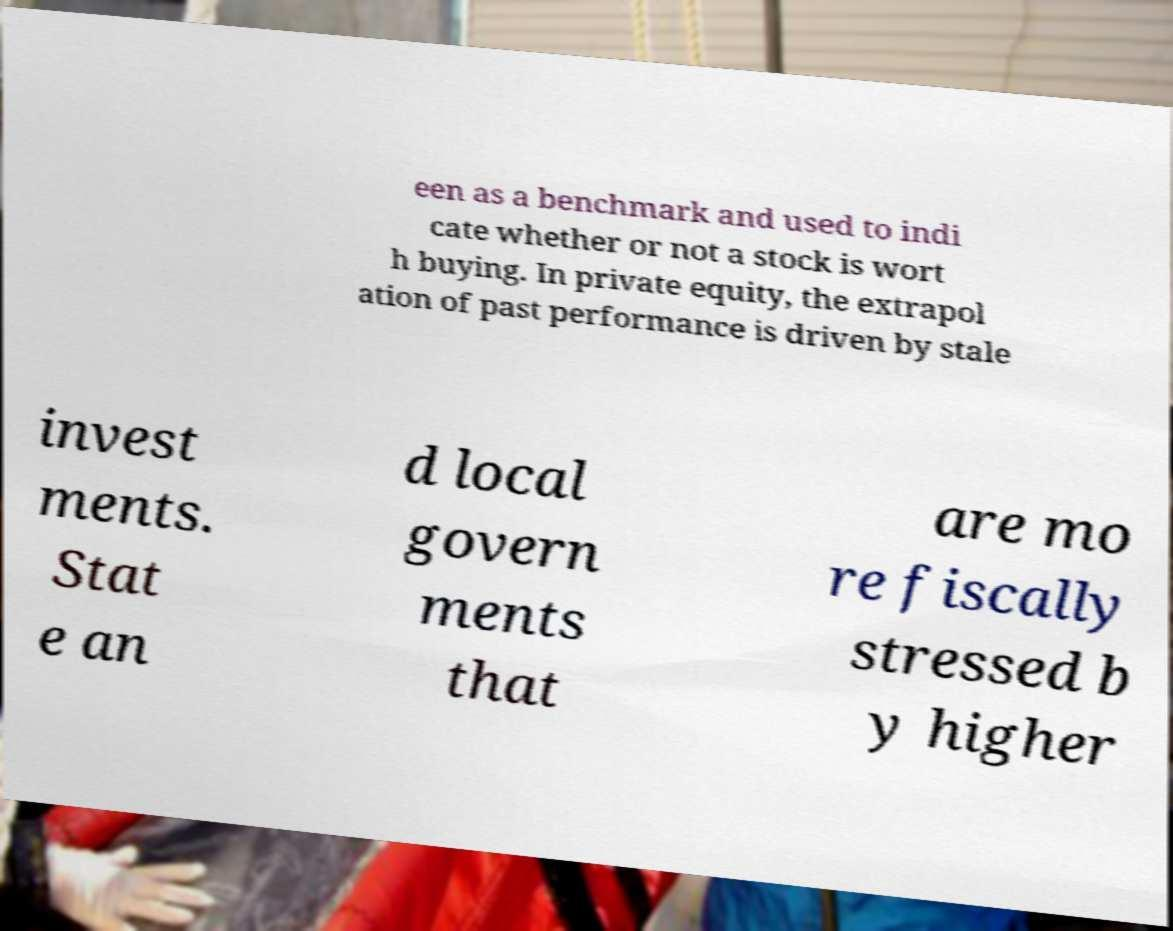What messages or text are displayed in this image? I need them in a readable, typed format. een as a benchmark and used to indi cate whether or not a stock is wort h buying. In private equity, the extrapol ation of past performance is driven by stale invest ments. Stat e an d local govern ments that are mo re fiscally stressed b y higher 